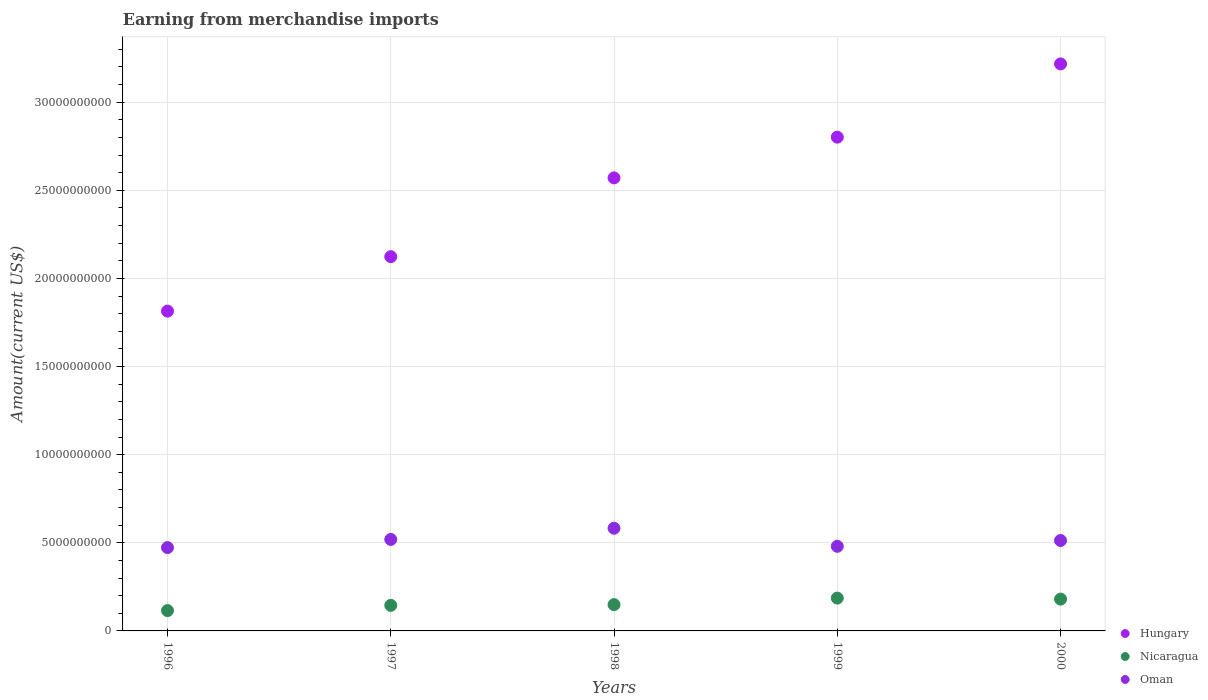Is the number of dotlines equal to the number of legend labels?
Ensure brevity in your answer.  Yes. What is the amount earned from merchandise imports in Oman in 1996?
Make the answer very short. 4.73e+09. Across all years, what is the maximum amount earned from merchandise imports in Oman?
Offer a terse response. 5.83e+09. Across all years, what is the minimum amount earned from merchandise imports in Hungary?
Give a very brief answer. 1.81e+1. In which year was the amount earned from merchandise imports in Oman maximum?
Your answer should be very brief. 1998. What is the total amount earned from merchandise imports in Oman in the graph?
Provide a succinct answer. 2.57e+1. What is the difference between the amount earned from merchandise imports in Oman in 1996 and that in 1997?
Make the answer very short. -4.63e+08. What is the difference between the amount earned from merchandise imports in Oman in 1998 and the amount earned from merchandise imports in Nicaragua in 1996?
Make the answer very short. 4.67e+09. What is the average amount earned from merchandise imports in Nicaragua per year?
Offer a very short reply. 1.55e+09. In the year 1997, what is the difference between the amount earned from merchandise imports in Hungary and amount earned from merchandise imports in Nicaragua?
Your answer should be compact. 1.98e+1. In how many years, is the amount earned from merchandise imports in Hungary greater than 7000000000 US$?
Provide a short and direct response. 5. What is the ratio of the amount earned from merchandise imports in Oman in 1997 to that in 1998?
Offer a terse response. 0.89. Is the difference between the amount earned from merchandise imports in Hungary in 1996 and 1999 greater than the difference between the amount earned from merchandise imports in Nicaragua in 1996 and 1999?
Offer a terse response. No. What is the difference between the highest and the second highest amount earned from merchandise imports in Nicaragua?
Your answer should be compact. 5.70e+07. What is the difference between the highest and the lowest amount earned from merchandise imports in Nicaragua?
Your answer should be compact. 7.08e+08. Is it the case that in every year, the sum of the amount earned from merchandise imports in Nicaragua and amount earned from merchandise imports in Hungary  is greater than the amount earned from merchandise imports in Oman?
Offer a terse response. Yes. Is the amount earned from merchandise imports in Hungary strictly greater than the amount earned from merchandise imports in Oman over the years?
Ensure brevity in your answer.  Yes. Is the amount earned from merchandise imports in Oman strictly less than the amount earned from merchandise imports in Nicaragua over the years?
Your answer should be compact. No. How many dotlines are there?
Your answer should be compact. 3. How many years are there in the graph?
Offer a terse response. 5. What is the difference between two consecutive major ticks on the Y-axis?
Give a very brief answer. 5.00e+09. Are the values on the major ticks of Y-axis written in scientific E-notation?
Give a very brief answer. No. Does the graph contain grids?
Your response must be concise. Yes. Where does the legend appear in the graph?
Provide a succinct answer. Bottom right. What is the title of the graph?
Your answer should be compact. Earning from merchandise imports. Does "Heavily indebted poor countries" appear as one of the legend labels in the graph?
Offer a very short reply. No. What is the label or title of the Y-axis?
Give a very brief answer. Amount(current US$). What is the Amount(current US$) in Hungary in 1996?
Your answer should be compact. 1.81e+1. What is the Amount(current US$) of Nicaragua in 1996?
Make the answer very short. 1.15e+09. What is the Amount(current US$) of Oman in 1996?
Your answer should be compact. 4.73e+09. What is the Amount(current US$) of Hungary in 1997?
Make the answer very short. 2.12e+1. What is the Amount(current US$) of Nicaragua in 1997?
Offer a terse response. 1.45e+09. What is the Amount(current US$) in Oman in 1997?
Ensure brevity in your answer.  5.19e+09. What is the Amount(current US$) in Hungary in 1998?
Provide a succinct answer. 2.57e+1. What is the Amount(current US$) of Nicaragua in 1998?
Make the answer very short. 1.49e+09. What is the Amount(current US$) of Oman in 1998?
Your answer should be compact. 5.83e+09. What is the Amount(current US$) of Hungary in 1999?
Ensure brevity in your answer.  2.80e+1. What is the Amount(current US$) of Nicaragua in 1999?
Provide a short and direct response. 1.86e+09. What is the Amount(current US$) in Oman in 1999?
Ensure brevity in your answer.  4.80e+09. What is the Amount(current US$) in Hungary in 2000?
Your answer should be very brief. 3.22e+1. What is the Amount(current US$) of Nicaragua in 2000?
Your answer should be very brief. 1.80e+09. What is the Amount(current US$) in Oman in 2000?
Your answer should be compact. 5.13e+09. Across all years, what is the maximum Amount(current US$) in Hungary?
Your answer should be compact. 3.22e+1. Across all years, what is the maximum Amount(current US$) of Nicaragua?
Offer a terse response. 1.86e+09. Across all years, what is the maximum Amount(current US$) of Oman?
Provide a succinct answer. 5.83e+09. Across all years, what is the minimum Amount(current US$) of Hungary?
Give a very brief answer. 1.81e+1. Across all years, what is the minimum Amount(current US$) of Nicaragua?
Keep it short and to the point. 1.15e+09. Across all years, what is the minimum Amount(current US$) of Oman?
Provide a succinct answer. 4.73e+09. What is the total Amount(current US$) in Hungary in the graph?
Ensure brevity in your answer.  1.25e+11. What is the total Amount(current US$) of Nicaragua in the graph?
Your response must be concise. 7.76e+09. What is the total Amount(current US$) of Oman in the graph?
Provide a short and direct response. 2.57e+1. What is the difference between the Amount(current US$) in Hungary in 1996 and that in 1997?
Your response must be concise. -3.09e+09. What is the difference between the Amount(current US$) of Nicaragua in 1996 and that in 1997?
Give a very brief answer. -2.96e+08. What is the difference between the Amount(current US$) of Oman in 1996 and that in 1997?
Offer a very short reply. -4.63e+08. What is the difference between the Amount(current US$) in Hungary in 1996 and that in 1998?
Keep it short and to the point. -7.56e+09. What is the difference between the Amount(current US$) of Nicaragua in 1996 and that in 1998?
Give a very brief answer. -3.38e+08. What is the difference between the Amount(current US$) in Oman in 1996 and that in 1998?
Offer a very short reply. -1.10e+09. What is the difference between the Amount(current US$) of Hungary in 1996 and that in 1999?
Keep it short and to the point. -9.87e+09. What is the difference between the Amount(current US$) of Nicaragua in 1996 and that in 1999?
Your answer should be very brief. -7.08e+08. What is the difference between the Amount(current US$) in Oman in 1996 and that in 1999?
Ensure brevity in your answer.  -7.30e+07. What is the difference between the Amount(current US$) of Hungary in 1996 and that in 2000?
Your answer should be very brief. -1.40e+1. What is the difference between the Amount(current US$) in Nicaragua in 1996 and that in 2000?
Give a very brief answer. -6.51e+08. What is the difference between the Amount(current US$) of Oman in 1996 and that in 2000?
Your answer should be very brief. -4.03e+08. What is the difference between the Amount(current US$) of Hungary in 1997 and that in 1998?
Make the answer very short. -4.47e+09. What is the difference between the Amount(current US$) in Nicaragua in 1997 and that in 1998?
Your response must be concise. -4.20e+07. What is the difference between the Amount(current US$) of Oman in 1997 and that in 1998?
Provide a succinct answer. -6.35e+08. What is the difference between the Amount(current US$) of Hungary in 1997 and that in 1999?
Offer a very short reply. -6.78e+09. What is the difference between the Amount(current US$) of Nicaragua in 1997 and that in 1999?
Ensure brevity in your answer.  -4.12e+08. What is the difference between the Amount(current US$) of Oman in 1997 and that in 1999?
Make the answer very short. 3.90e+08. What is the difference between the Amount(current US$) in Hungary in 1997 and that in 2000?
Your answer should be compact. -1.09e+1. What is the difference between the Amount(current US$) of Nicaragua in 1997 and that in 2000?
Ensure brevity in your answer.  -3.55e+08. What is the difference between the Amount(current US$) of Oman in 1997 and that in 2000?
Offer a terse response. 6.00e+07. What is the difference between the Amount(current US$) in Hungary in 1998 and that in 1999?
Offer a terse response. -2.31e+09. What is the difference between the Amount(current US$) in Nicaragua in 1998 and that in 1999?
Give a very brief answer. -3.70e+08. What is the difference between the Amount(current US$) of Oman in 1998 and that in 1999?
Your answer should be very brief. 1.02e+09. What is the difference between the Amount(current US$) in Hungary in 1998 and that in 2000?
Your answer should be compact. -6.47e+09. What is the difference between the Amount(current US$) in Nicaragua in 1998 and that in 2000?
Your answer should be very brief. -3.13e+08. What is the difference between the Amount(current US$) in Oman in 1998 and that in 2000?
Keep it short and to the point. 6.95e+08. What is the difference between the Amount(current US$) of Hungary in 1999 and that in 2000?
Your answer should be compact. -4.16e+09. What is the difference between the Amount(current US$) in Nicaragua in 1999 and that in 2000?
Offer a terse response. 5.70e+07. What is the difference between the Amount(current US$) of Oman in 1999 and that in 2000?
Provide a succinct answer. -3.30e+08. What is the difference between the Amount(current US$) of Hungary in 1996 and the Amount(current US$) of Nicaragua in 1997?
Provide a succinct answer. 1.67e+1. What is the difference between the Amount(current US$) of Hungary in 1996 and the Amount(current US$) of Oman in 1997?
Ensure brevity in your answer.  1.30e+1. What is the difference between the Amount(current US$) of Nicaragua in 1996 and the Amount(current US$) of Oman in 1997?
Your answer should be compact. -4.04e+09. What is the difference between the Amount(current US$) in Hungary in 1996 and the Amount(current US$) in Nicaragua in 1998?
Your response must be concise. 1.67e+1. What is the difference between the Amount(current US$) of Hungary in 1996 and the Amount(current US$) of Oman in 1998?
Provide a succinct answer. 1.23e+1. What is the difference between the Amount(current US$) in Nicaragua in 1996 and the Amount(current US$) in Oman in 1998?
Give a very brief answer. -4.67e+09. What is the difference between the Amount(current US$) in Hungary in 1996 and the Amount(current US$) in Nicaragua in 1999?
Your answer should be compact. 1.63e+1. What is the difference between the Amount(current US$) in Hungary in 1996 and the Amount(current US$) in Oman in 1999?
Provide a succinct answer. 1.33e+1. What is the difference between the Amount(current US$) of Nicaragua in 1996 and the Amount(current US$) of Oman in 1999?
Offer a very short reply. -3.65e+09. What is the difference between the Amount(current US$) in Hungary in 1996 and the Amount(current US$) in Nicaragua in 2000?
Your response must be concise. 1.63e+1. What is the difference between the Amount(current US$) of Hungary in 1996 and the Amount(current US$) of Oman in 2000?
Ensure brevity in your answer.  1.30e+1. What is the difference between the Amount(current US$) of Nicaragua in 1996 and the Amount(current US$) of Oman in 2000?
Ensure brevity in your answer.  -3.98e+09. What is the difference between the Amount(current US$) of Hungary in 1997 and the Amount(current US$) of Nicaragua in 1998?
Provide a succinct answer. 1.97e+1. What is the difference between the Amount(current US$) in Hungary in 1997 and the Amount(current US$) in Oman in 1998?
Provide a short and direct response. 1.54e+1. What is the difference between the Amount(current US$) in Nicaragua in 1997 and the Amount(current US$) in Oman in 1998?
Your answer should be compact. -4.38e+09. What is the difference between the Amount(current US$) in Hungary in 1997 and the Amount(current US$) in Nicaragua in 1999?
Give a very brief answer. 1.94e+1. What is the difference between the Amount(current US$) in Hungary in 1997 and the Amount(current US$) in Oman in 1999?
Provide a succinct answer. 1.64e+1. What is the difference between the Amount(current US$) in Nicaragua in 1997 and the Amount(current US$) in Oman in 1999?
Your answer should be very brief. -3.35e+09. What is the difference between the Amount(current US$) of Hungary in 1997 and the Amount(current US$) of Nicaragua in 2000?
Offer a terse response. 1.94e+1. What is the difference between the Amount(current US$) of Hungary in 1997 and the Amount(current US$) of Oman in 2000?
Your response must be concise. 1.61e+1. What is the difference between the Amount(current US$) in Nicaragua in 1997 and the Amount(current US$) in Oman in 2000?
Provide a short and direct response. -3.68e+09. What is the difference between the Amount(current US$) in Hungary in 1998 and the Amount(current US$) in Nicaragua in 1999?
Your answer should be very brief. 2.38e+1. What is the difference between the Amount(current US$) in Hungary in 1998 and the Amount(current US$) in Oman in 1999?
Offer a terse response. 2.09e+1. What is the difference between the Amount(current US$) of Nicaragua in 1998 and the Amount(current US$) of Oman in 1999?
Offer a very short reply. -3.31e+09. What is the difference between the Amount(current US$) of Hungary in 1998 and the Amount(current US$) of Nicaragua in 2000?
Offer a very short reply. 2.39e+1. What is the difference between the Amount(current US$) of Hungary in 1998 and the Amount(current US$) of Oman in 2000?
Offer a terse response. 2.06e+1. What is the difference between the Amount(current US$) in Nicaragua in 1998 and the Amount(current US$) in Oman in 2000?
Keep it short and to the point. -3.64e+09. What is the difference between the Amount(current US$) of Hungary in 1999 and the Amount(current US$) of Nicaragua in 2000?
Make the answer very short. 2.62e+1. What is the difference between the Amount(current US$) in Hungary in 1999 and the Amount(current US$) in Oman in 2000?
Ensure brevity in your answer.  2.29e+1. What is the difference between the Amount(current US$) of Nicaragua in 1999 and the Amount(current US$) of Oman in 2000?
Make the answer very short. -3.27e+09. What is the average Amount(current US$) of Hungary per year?
Keep it short and to the point. 2.51e+1. What is the average Amount(current US$) of Nicaragua per year?
Keep it short and to the point. 1.55e+09. What is the average Amount(current US$) in Oman per year?
Make the answer very short. 5.14e+09. In the year 1996, what is the difference between the Amount(current US$) of Hungary and Amount(current US$) of Nicaragua?
Offer a terse response. 1.70e+1. In the year 1996, what is the difference between the Amount(current US$) in Hungary and Amount(current US$) in Oman?
Provide a succinct answer. 1.34e+1. In the year 1996, what is the difference between the Amount(current US$) in Nicaragua and Amount(current US$) in Oman?
Your answer should be very brief. -3.57e+09. In the year 1997, what is the difference between the Amount(current US$) in Hungary and Amount(current US$) in Nicaragua?
Provide a short and direct response. 1.98e+1. In the year 1997, what is the difference between the Amount(current US$) of Hungary and Amount(current US$) of Oman?
Ensure brevity in your answer.  1.60e+1. In the year 1997, what is the difference between the Amount(current US$) of Nicaragua and Amount(current US$) of Oman?
Provide a short and direct response. -3.74e+09. In the year 1998, what is the difference between the Amount(current US$) of Hungary and Amount(current US$) of Nicaragua?
Provide a succinct answer. 2.42e+1. In the year 1998, what is the difference between the Amount(current US$) of Hungary and Amount(current US$) of Oman?
Provide a succinct answer. 1.99e+1. In the year 1998, what is the difference between the Amount(current US$) of Nicaragua and Amount(current US$) of Oman?
Provide a short and direct response. -4.33e+09. In the year 1999, what is the difference between the Amount(current US$) of Hungary and Amount(current US$) of Nicaragua?
Your answer should be very brief. 2.62e+1. In the year 1999, what is the difference between the Amount(current US$) in Hungary and Amount(current US$) in Oman?
Your response must be concise. 2.32e+1. In the year 1999, what is the difference between the Amount(current US$) of Nicaragua and Amount(current US$) of Oman?
Ensure brevity in your answer.  -2.94e+09. In the year 2000, what is the difference between the Amount(current US$) of Hungary and Amount(current US$) of Nicaragua?
Your response must be concise. 3.04e+1. In the year 2000, what is the difference between the Amount(current US$) in Hungary and Amount(current US$) in Oman?
Offer a very short reply. 2.70e+1. In the year 2000, what is the difference between the Amount(current US$) of Nicaragua and Amount(current US$) of Oman?
Your response must be concise. -3.33e+09. What is the ratio of the Amount(current US$) in Hungary in 1996 to that in 1997?
Offer a very short reply. 0.85. What is the ratio of the Amount(current US$) of Nicaragua in 1996 to that in 1997?
Provide a succinct answer. 0.8. What is the ratio of the Amount(current US$) of Oman in 1996 to that in 1997?
Offer a very short reply. 0.91. What is the ratio of the Amount(current US$) of Hungary in 1996 to that in 1998?
Keep it short and to the point. 0.71. What is the ratio of the Amount(current US$) of Nicaragua in 1996 to that in 1998?
Your answer should be compact. 0.77. What is the ratio of the Amount(current US$) in Oman in 1996 to that in 1998?
Keep it short and to the point. 0.81. What is the ratio of the Amount(current US$) of Hungary in 1996 to that in 1999?
Ensure brevity in your answer.  0.65. What is the ratio of the Amount(current US$) of Nicaragua in 1996 to that in 1999?
Keep it short and to the point. 0.62. What is the ratio of the Amount(current US$) in Hungary in 1996 to that in 2000?
Keep it short and to the point. 0.56. What is the ratio of the Amount(current US$) of Nicaragua in 1996 to that in 2000?
Ensure brevity in your answer.  0.64. What is the ratio of the Amount(current US$) of Oman in 1996 to that in 2000?
Make the answer very short. 0.92. What is the ratio of the Amount(current US$) in Hungary in 1997 to that in 1998?
Your answer should be compact. 0.83. What is the ratio of the Amount(current US$) in Nicaragua in 1997 to that in 1998?
Offer a very short reply. 0.97. What is the ratio of the Amount(current US$) in Oman in 1997 to that in 1998?
Your answer should be very brief. 0.89. What is the ratio of the Amount(current US$) of Hungary in 1997 to that in 1999?
Keep it short and to the point. 0.76. What is the ratio of the Amount(current US$) in Nicaragua in 1997 to that in 1999?
Your answer should be very brief. 0.78. What is the ratio of the Amount(current US$) in Oman in 1997 to that in 1999?
Make the answer very short. 1.08. What is the ratio of the Amount(current US$) in Hungary in 1997 to that in 2000?
Ensure brevity in your answer.  0.66. What is the ratio of the Amount(current US$) in Nicaragua in 1997 to that in 2000?
Your response must be concise. 0.8. What is the ratio of the Amount(current US$) of Oman in 1997 to that in 2000?
Your response must be concise. 1.01. What is the ratio of the Amount(current US$) in Hungary in 1998 to that in 1999?
Give a very brief answer. 0.92. What is the ratio of the Amount(current US$) in Nicaragua in 1998 to that in 1999?
Make the answer very short. 0.8. What is the ratio of the Amount(current US$) of Oman in 1998 to that in 1999?
Ensure brevity in your answer.  1.21. What is the ratio of the Amount(current US$) in Hungary in 1998 to that in 2000?
Offer a terse response. 0.8. What is the ratio of the Amount(current US$) of Nicaragua in 1998 to that in 2000?
Your answer should be compact. 0.83. What is the ratio of the Amount(current US$) in Oman in 1998 to that in 2000?
Make the answer very short. 1.14. What is the ratio of the Amount(current US$) in Hungary in 1999 to that in 2000?
Your answer should be compact. 0.87. What is the ratio of the Amount(current US$) of Nicaragua in 1999 to that in 2000?
Keep it short and to the point. 1.03. What is the ratio of the Amount(current US$) of Oman in 1999 to that in 2000?
Ensure brevity in your answer.  0.94. What is the difference between the highest and the second highest Amount(current US$) of Hungary?
Your answer should be very brief. 4.16e+09. What is the difference between the highest and the second highest Amount(current US$) of Nicaragua?
Your answer should be very brief. 5.70e+07. What is the difference between the highest and the second highest Amount(current US$) in Oman?
Offer a very short reply. 6.35e+08. What is the difference between the highest and the lowest Amount(current US$) in Hungary?
Offer a very short reply. 1.40e+1. What is the difference between the highest and the lowest Amount(current US$) of Nicaragua?
Offer a very short reply. 7.08e+08. What is the difference between the highest and the lowest Amount(current US$) in Oman?
Your answer should be very brief. 1.10e+09. 